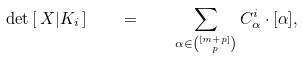<formula> <loc_0><loc_0><loc_500><loc_500>\det \, [ \, X | K _ { i } \, ] \quad = \quad \sum _ { \alpha \in \binom { [ m + p ] } { p } } C _ { \alpha } ^ { i } \cdot [ \alpha ] ,</formula> 